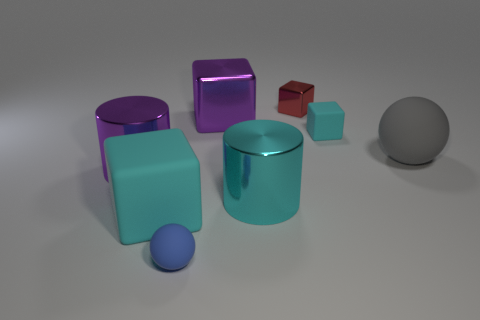What number of large red matte spheres are there?
Make the answer very short. 0. How many cylinders are small brown metallic things or red things?
Provide a succinct answer. 0. There is a purple metal thing that is behind the gray thing; how many metal objects are on the left side of it?
Offer a terse response. 1. Is the big purple block made of the same material as the red cube?
Ensure brevity in your answer.  Yes. There is another block that is the same color as the large matte cube; what size is it?
Your answer should be very brief. Small. Is there a small cylinder that has the same material as the red cube?
Your answer should be compact. No. What color is the big metallic object in front of the large shiny cylinder that is to the left of the large block that is in front of the big rubber ball?
Your answer should be very brief. Cyan. What number of blue things are matte spheres or tiny matte spheres?
Keep it short and to the point. 1. How many purple objects have the same shape as the gray rubber thing?
Offer a terse response. 0. There is a cyan metal thing that is the same size as the purple metal cube; what shape is it?
Give a very brief answer. Cylinder. 